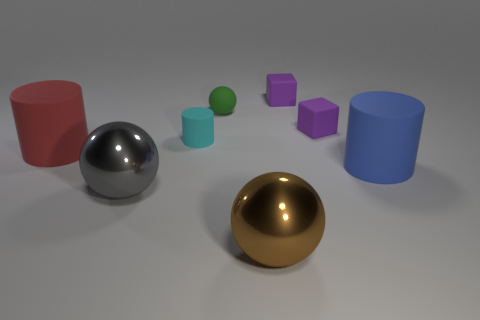What is the shape of the cyan matte thing?
Ensure brevity in your answer.  Cylinder. There is a gray metallic thing; are there any large rubber objects in front of it?
Provide a succinct answer. No. Do the brown thing and the big cylinder to the left of the cyan cylinder have the same material?
Keep it short and to the point. No. There is a large matte thing in front of the red rubber cylinder; is its shape the same as the cyan matte thing?
Give a very brief answer. Yes. How many small purple things are the same material as the blue thing?
Provide a succinct answer. 2. What number of things are big things that are to the left of the cyan rubber cylinder or cyan cylinders?
Offer a very short reply. 3. How big is the cyan matte object?
Provide a succinct answer. Small. The cylinder to the right of the small cyan thing behind the red cylinder is made of what material?
Your response must be concise. Rubber. There is a purple matte cube behind the green matte ball; is its size the same as the green ball?
Your answer should be very brief. Yes. How many things are big rubber cylinders that are to the right of the brown sphere or big matte cylinders that are right of the gray ball?
Ensure brevity in your answer.  1. 